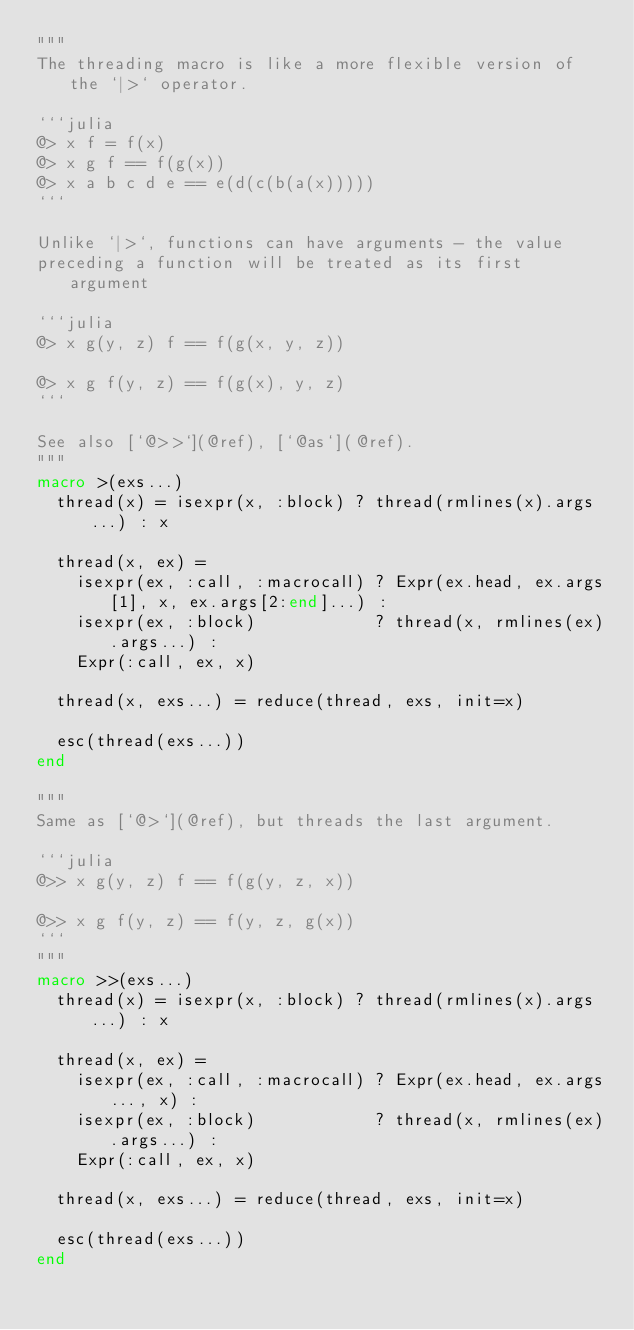<code> <loc_0><loc_0><loc_500><loc_500><_Julia_>"""
The threading macro is like a more flexible version of the `|>` operator.

```julia
@> x f = f(x)
@> x g f == f(g(x))
@> x a b c d e == e(d(c(b(a(x)))))
```

Unlike `|>`, functions can have arguments - the value
preceding a function will be treated as its first argument

```julia
@> x g(y, z) f == f(g(x, y, z))

@> x g f(y, z) == f(g(x), y, z)
```

See also [`@>>`](@ref), [`@as`](@ref).
"""
macro >(exs...)
  thread(x) = isexpr(x, :block) ? thread(rmlines(x).args...) : x

  thread(x, ex) =
    isexpr(ex, :call, :macrocall) ? Expr(ex.head, ex.args[1], x, ex.args[2:end]...) :
    isexpr(ex, :block)            ? thread(x, rmlines(ex).args...) :
    Expr(:call, ex, x)

  thread(x, exs...) = reduce(thread, exs, init=x)

  esc(thread(exs...))
end

"""
Same as [`@>`](@ref), but threads the last argument.

```julia
@>> x g(y, z) f == f(g(y, z, x))

@>> x g f(y, z) == f(y, z, g(x))
```
"""
macro >>(exs...)
  thread(x) = isexpr(x, :block) ? thread(rmlines(x).args...) : x

  thread(x, ex) =
    isexpr(ex, :call, :macrocall) ? Expr(ex.head, ex.args..., x) :
    isexpr(ex, :block)            ? thread(x, rmlines(ex).args...) :
    Expr(:call, ex, x)

  thread(x, exs...) = reduce(thread, exs, init=x)

  esc(thread(exs...))
end
</code> 